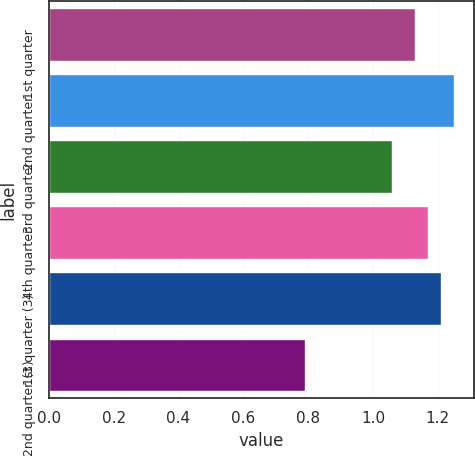Convert chart to OTSL. <chart><loc_0><loc_0><loc_500><loc_500><bar_chart><fcel>1st quarter<fcel>2nd quarter<fcel>3rd quarter<fcel>4th quarter<fcel>1st quarter (3)<fcel>2nd quarter (3)<nl><fcel>1.13<fcel>1.25<fcel>1.06<fcel>1.17<fcel>1.21<fcel>0.79<nl></chart> 